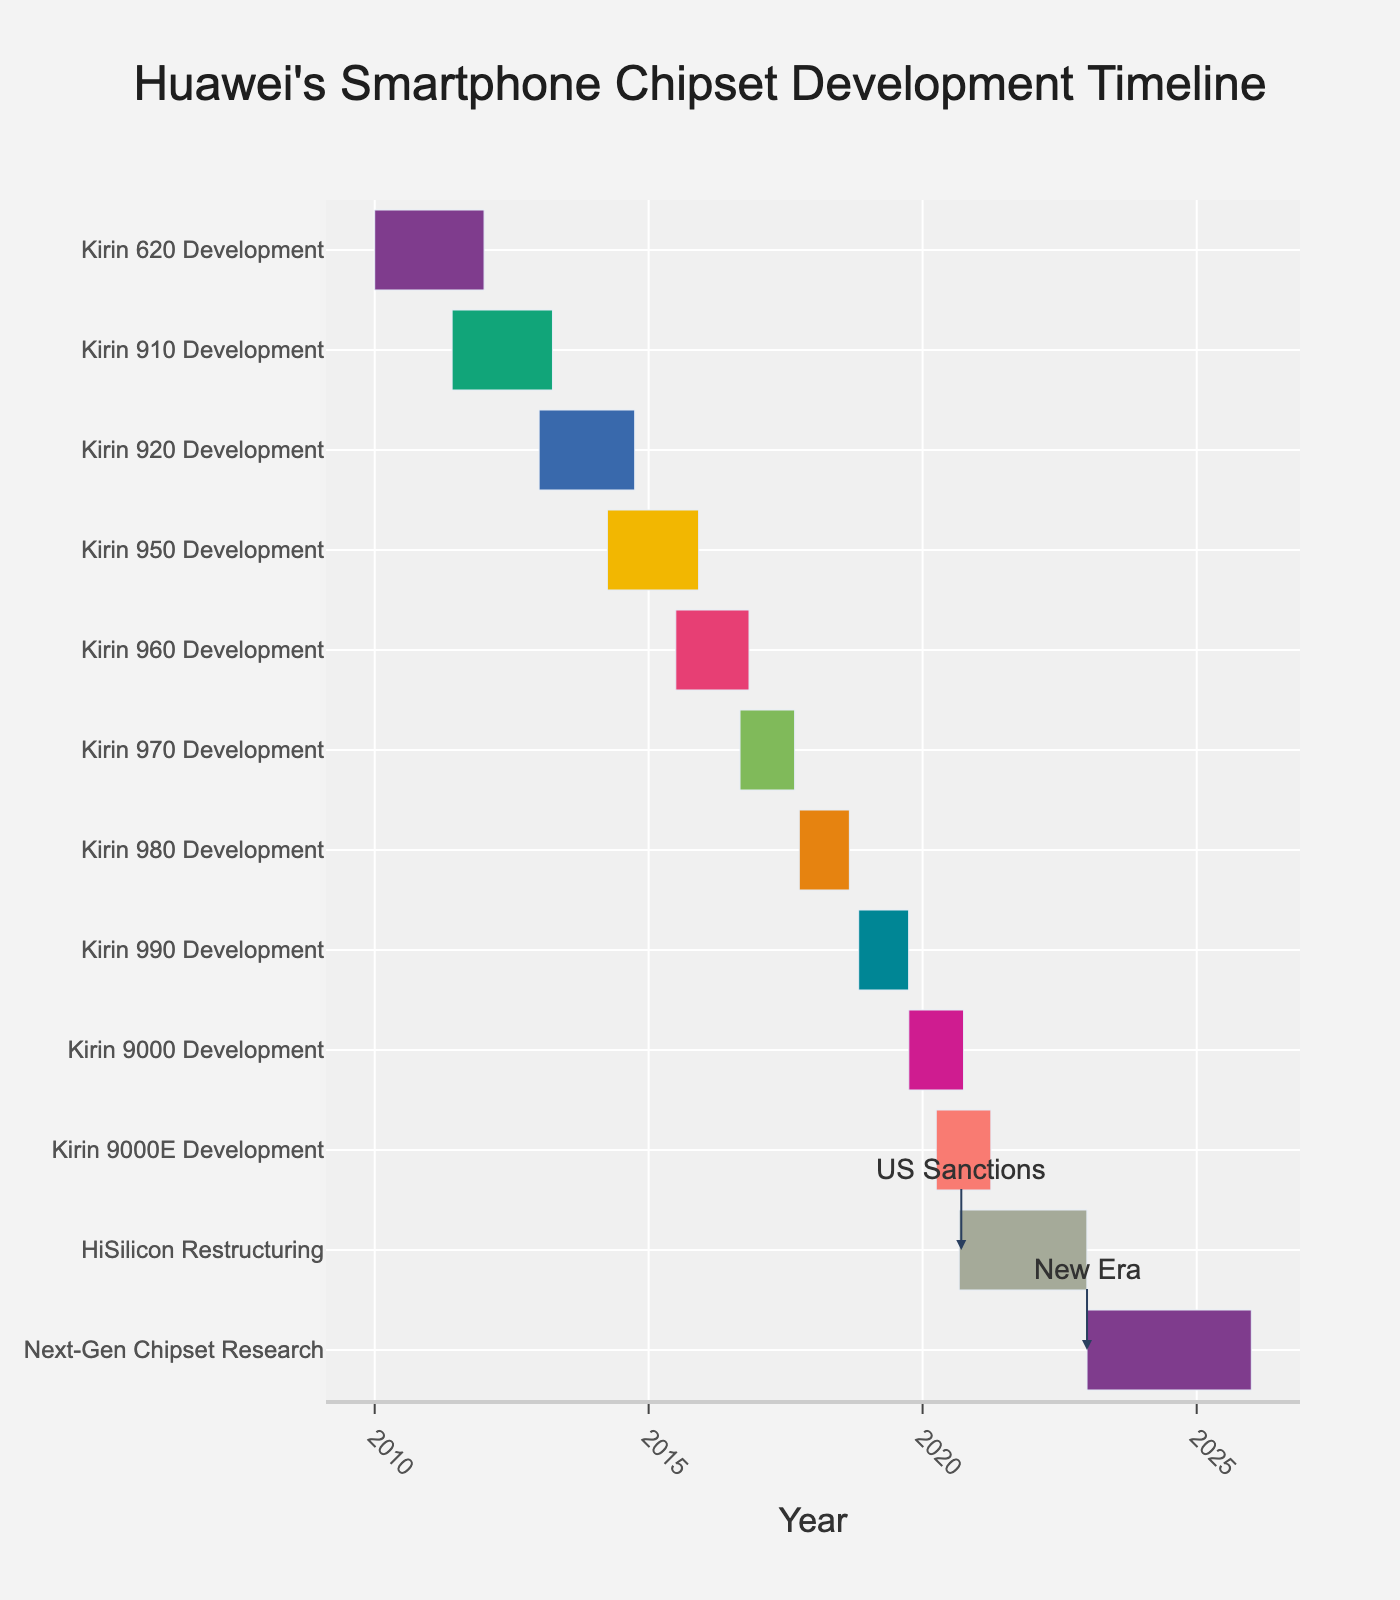What's the title of the Gantt chart? The title of the Gantt chart is typically displayed at the top of the figure. In this case, the title is "Huawei's Smartphone Chipset Development Timeline."
Answer: Huawei's Smartphone Chipset Development Timeline Which development phase started first? The first development phase starts at the earliest date on the x-axis. According to the chart, the "Kirin 620 Development" started on January 1, 2010.
Answer: Kirin 620 Development How long did the development of Kirin 920 take? To determine the duration, calculate the time difference between the start and end dates for "Kirin 920 Development." It started on January 1, 2013, and ended on September 30, 2014, which is approximately 1 year and 9 months.
Answer: 1 year and 9 months Which development phase has the shortest duration? By visually comparing the length of the bars in the chart, "Kirin 9000E Development" appears to be the shortest. It spans from April 1, 2020, to March 31, 2021, which is 11 months.
Answer: Kirin 9000E Development How many chipset developments took place before the "Kirin 950 Development"? Examine the order and dates of each development phase. "Kirin 950 Development" started on April 1, 2014. Before that, three developments occurred: "Kirin 620," "Kirin 910," and "Kirin 920."
Answer: 3 How many developments occurred after the HiSilicon restructuring? The end date of the HiSilicon restructuring is December 31, 2022. Post this restructuring, one more task appears, which is "Next-Gen Chipset Research."
Answer: 1 Between which years did Huawei experience a significant restructuring? Look for the "HiSilicon Restructuring" line. According to the chart, this restructuring happened from September 1, 2020, to December 31, 2022.
Answer: 2020 to 2022 What's the duration difference between "Kirin 950 Development" and "Kirin 960 Development"? Calculate the duration for both developments: "Kirin 950" (1 year and 7 months) and "Kirin 960" (1 year and 4 months). The difference is 3 months.
Answer: 3 months Which development spans the longest period? Visually, the longest bar on the chart represents "Next-Gen Chipset Research," lasting from January 1, 2023, to December 31, 2025. This period is 3 years.
Answer: Next-Gen Chipset Research Was there any overlap between "Kirin 980 Development" and "Kirin 990 Development"? Check the start and end dates: "Kirin 980 Development" (October 1, 2017, to August 31, 2018) and "Kirin 990 Development" (November 1, 2018, to September 30, 2019). There is no overlap.
Answer: No 